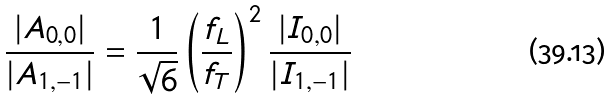Convert formula to latex. <formula><loc_0><loc_0><loc_500><loc_500>\frac { | A _ { 0 , 0 } | } { | A _ { 1 , - 1 } | } = \frac { 1 } { \sqrt { 6 } } \left ( \frac { f _ { L } } { f _ { T } } \right ) ^ { 2 } \frac { | I _ { 0 , 0 } | } { | I _ { 1 , - 1 } | }</formula> 